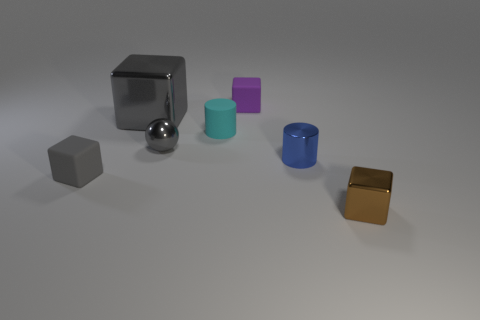Add 2 gray metallic things. How many objects exist? 9 Subtract all cubes. How many objects are left? 3 Add 7 tiny cyan shiny objects. How many tiny cyan shiny objects exist? 7 Subtract 0 blue spheres. How many objects are left? 7 Subtract all blue cylinders. Subtract all small metal cubes. How many objects are left? 5 Add 6 small matte cubes. How many small matte cubes are left? 8 